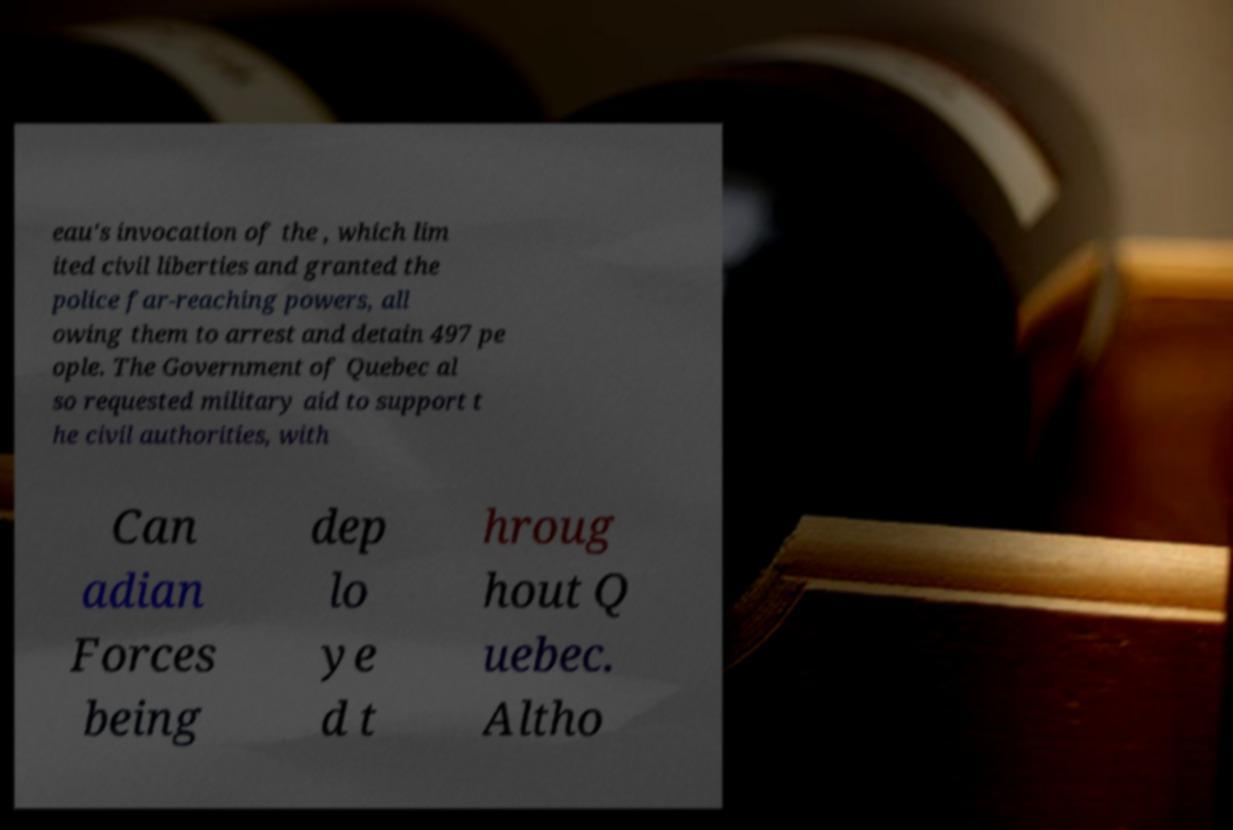Please read and relay the text visible in this image. What does it say? eau's invocation of the , which lim ited civil liberties and granted the police far-reaching powers, all owing them to arrest and detain 497 pe ople. The Government of Quebec al so requested military aid to support t he civil authorities, with Can adian Forces being dep lo ye d t hroug hout Q uebec. Altho 